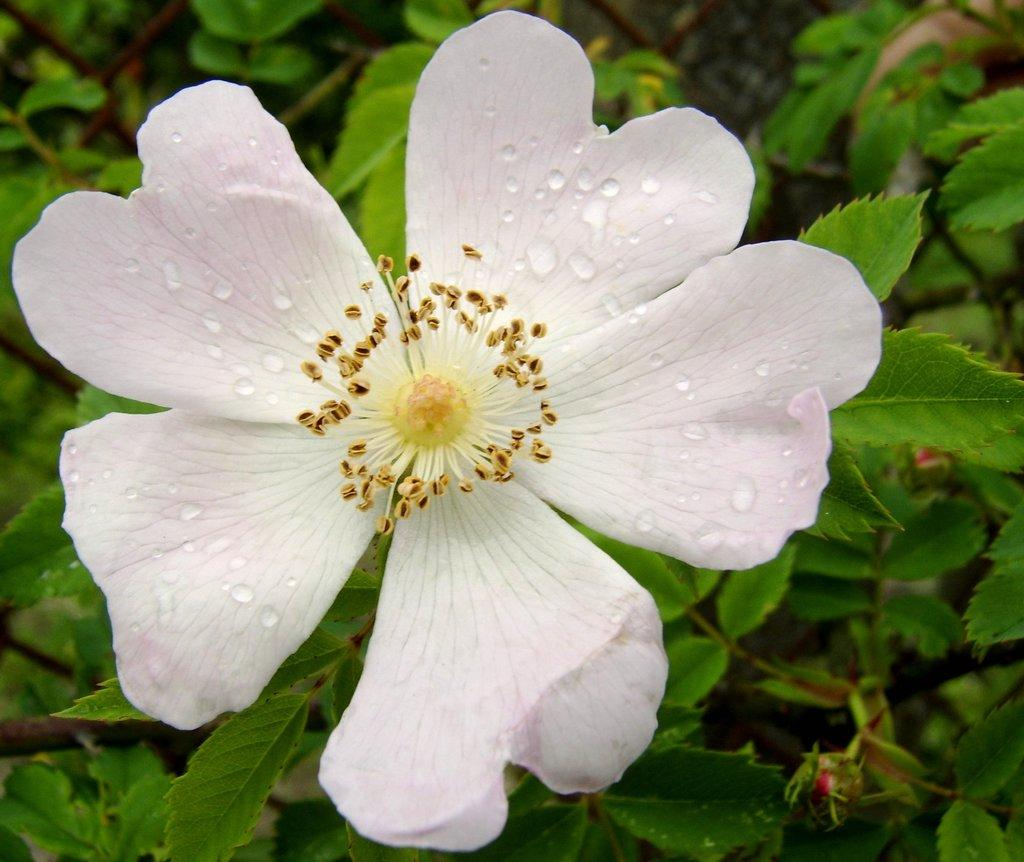What is the main subject of the image? There is a flower in the image. What is the color of the flower? The flower is white in color. Are there any other parts of the plant visible in the image? Yes, there are leaves associated with the flower. What can be seen on the surface of the flower? There are water droplets on the flower. What type of produce is being used as fuel for the iron in the image? There is no produce, iron, or fuel present in the image; it features a white flower with leaves and water droplets. 